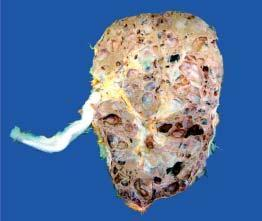re the amyloid deposits distorted due to cystic change?
Answer the question using a single word or phrase. No 